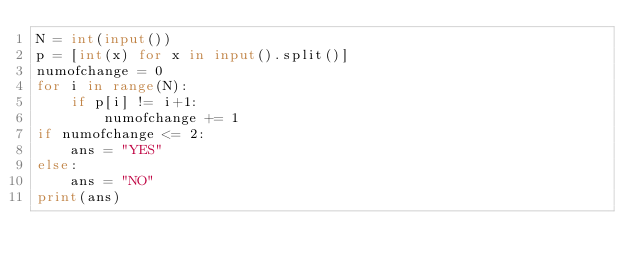<code> <loc_0><loc_0><loc_500><loc_500><_Python_>N = int(input())
p = [int(x) for x in input().split()]
numofchange = 0
for i in range(N):
    if p[i] != i+1:
        numofchange += 1
if numofchange <= 2:
    ans = "YES"
else:
    ans = "NO"
print(ans)
</code> 